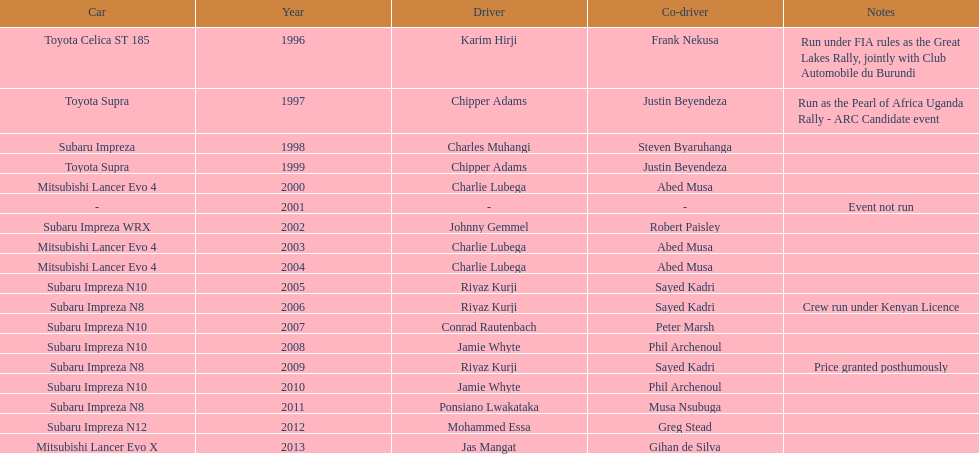Which was the only year that the event was not run? 2001. 